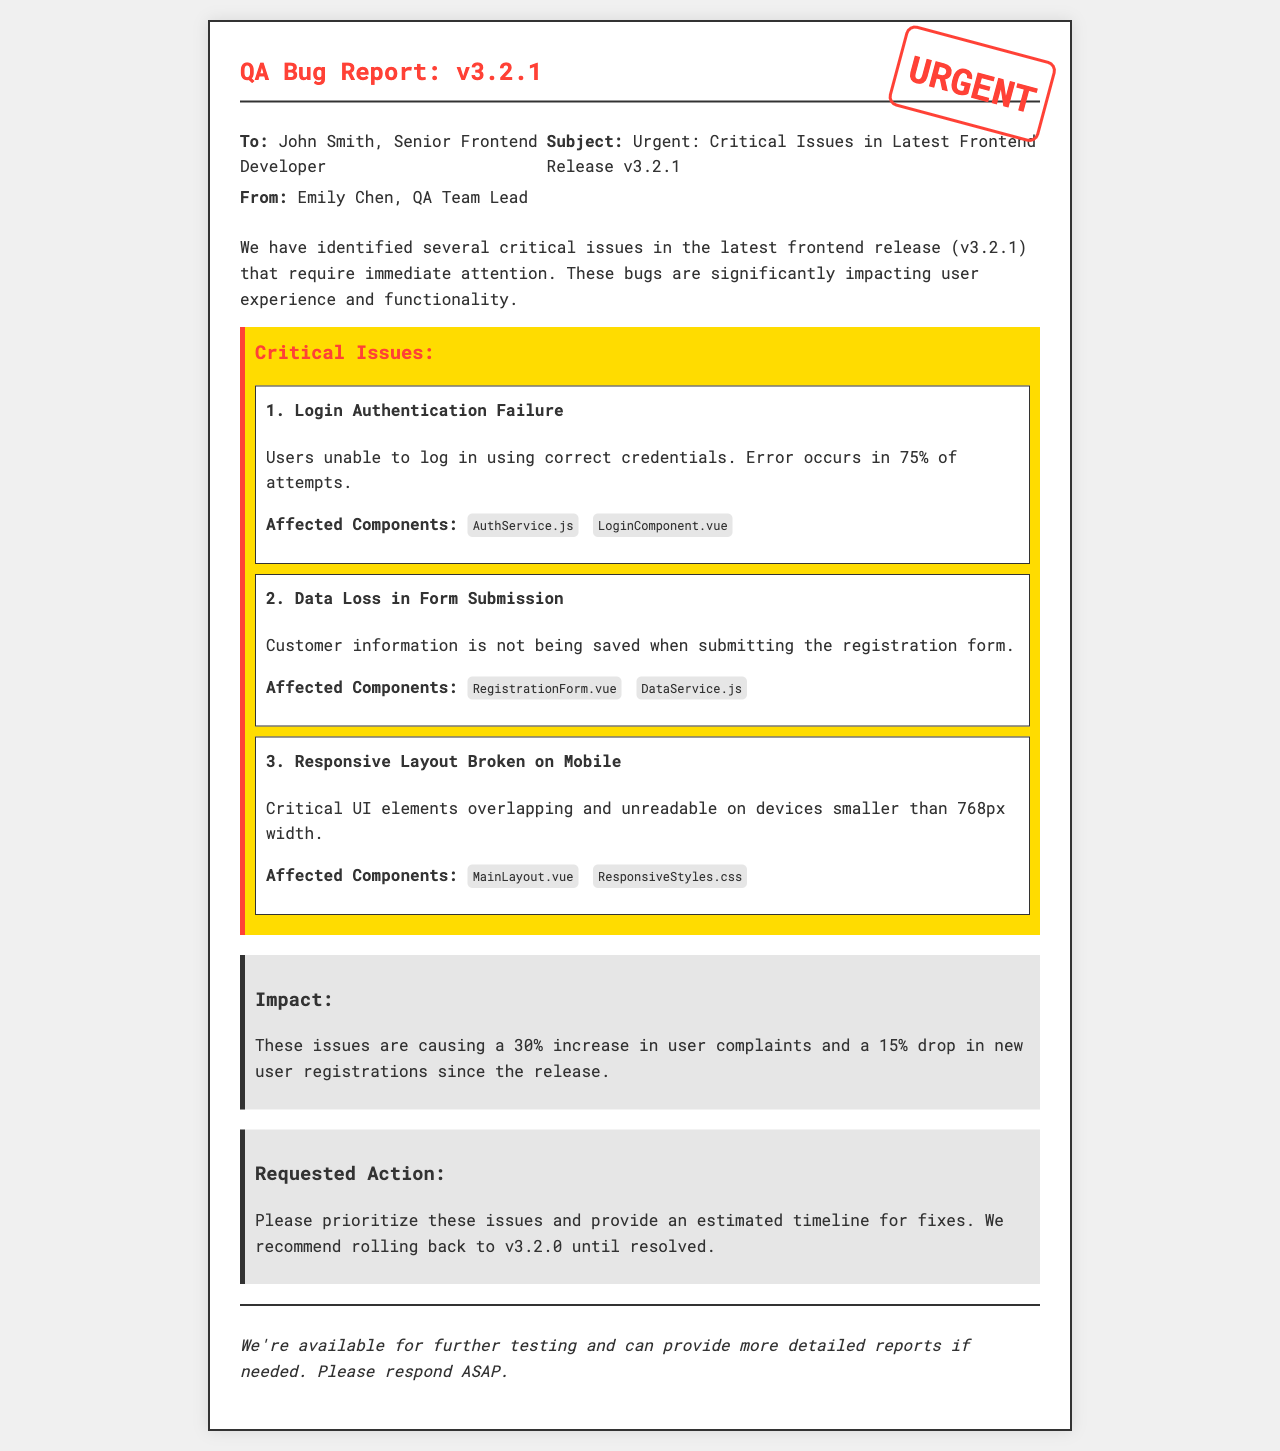What is the version of the frontend release? The document states that the latest frontend release is version 3.2.1.
Answer: v3.2.1 Who is the recipient of the fax? The "To" section specifies that John Smith, Senior Frontend Developer, is the recipient.
Answer: John Smith What is the first critical issue mentioned? The first critical issue listed in the document is "Login Authentication Failure."
Answer: Login Authentication Failure What percentage of login attempts are failing? The document notes that users are unable to log in correctly 75% of the time.
Answer: 75% What component is affected by the data loss issue? The "Data Loss in Form Submission" issue affects both the RegistrationForm.vue and DataService.js components.
Answer: RegistrationForm.vue, DataService.js What is the impact on user complaints? The impact section indicates that there is a 30% increase in user complaints since the release.
Answer: 30% What action is requested regarding the issues? The document requests prioritization of the issues and an estimated timeline for fixes.
Answer: Prioritize issues and estimated timeline for fixes What is the recommendation until the issues are resolved? The document suggests rolling back to the previous version, v3.2.0, until the issues are fixed.
Answer: Roll back to v3.2.0 What color is the urgent stamp? The urgent stamp in the document is in the color red.
Answer: Red 